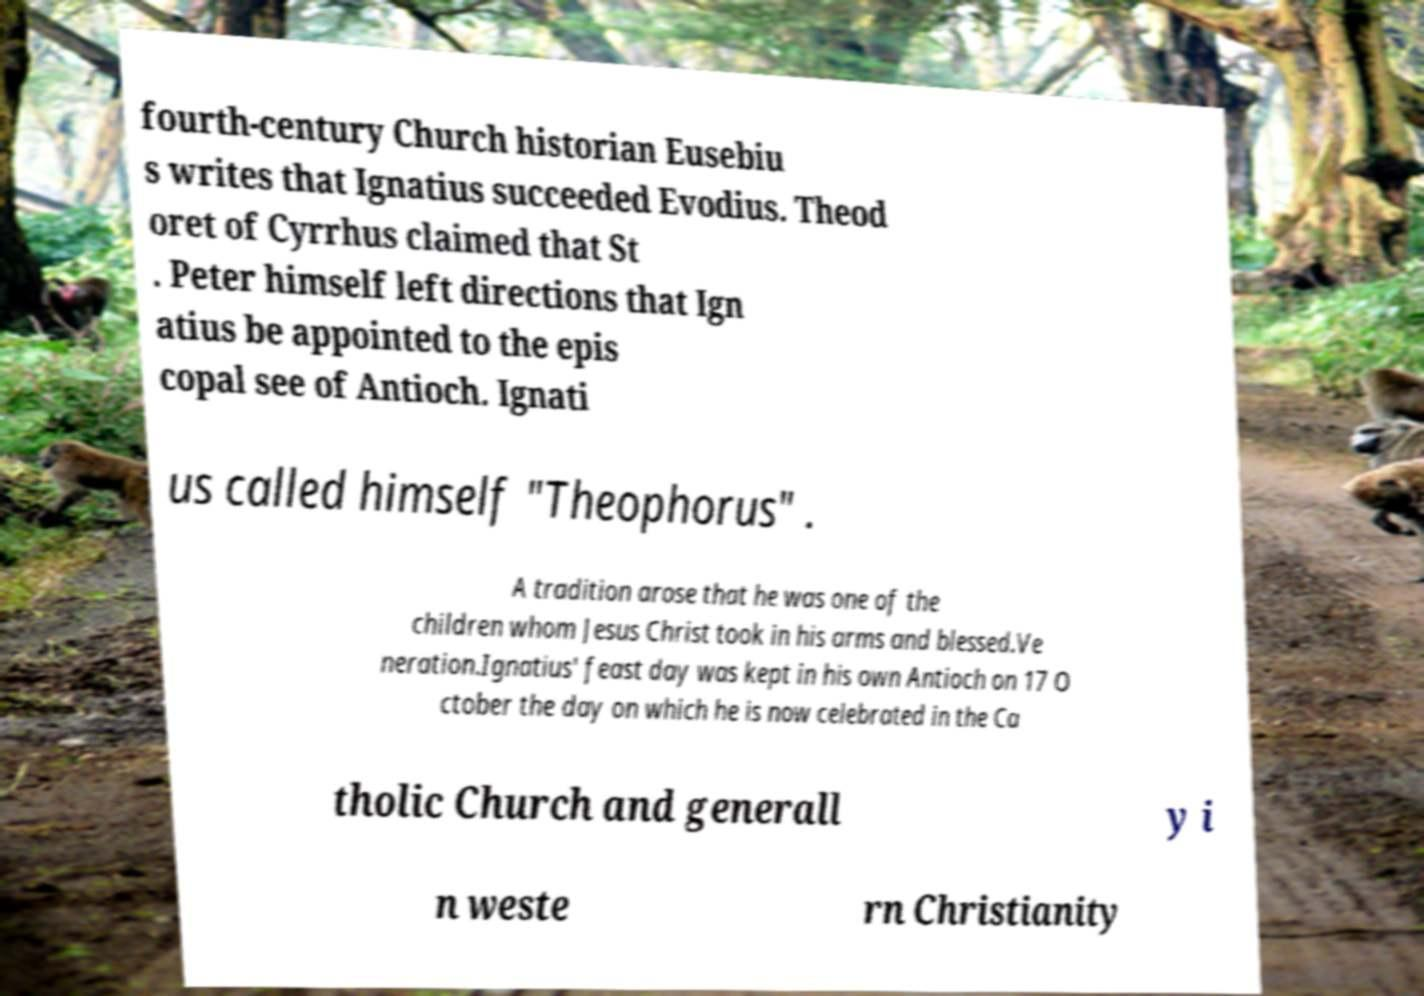There's text embedded in this image that I need extracted. Can you transcribe it verbatim? fourth-century Church historian Eusebiu s writes that Ignatius succeeded Evodius. Theod oret of Cyrrhus claimed that St . Peter himself left directions that Ign atius be appointed to the epis copal see of Antioch. Ignati us called himself "Theophorus" . A tradition arose that he was one of the children whom Jesus Christ took in his arms and blessed.Ve neration.Ignatius' feast day was kept in his own Antioch on 17 O ctober the day on which he is now celebrated in the Ca tholic Church and generall y i n weste rn Christianity 